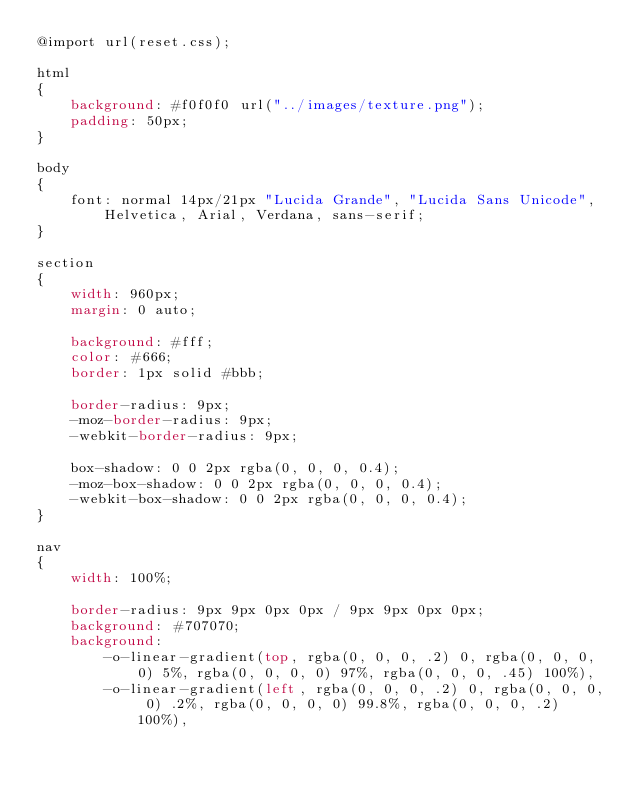<code> <loc_0><loc_0><loc_500><loc_500><_CSS_>@import url(reset.css);

html
{
	background: #f0f0f0 url("../images/texture.png");
	padding: 50px;
}

body
{
	font: normal 14px/21px "Lucida Grande", "Lucida Sans Unicode", Helvetica, Arial, Verdana, sans-serif;
}

section
{
	width: 960px;
	margin: 0 auto;

	background: #fff;
	color: #666;
	border: 1px solid #bbb;

	border-radius: 9px;
	-moz-border-radius: 9px;
	-webkit-border-radius: 9px;

	box-shadow: 0 0 2px rgba(0, 0, 0, 0.4);
	-moz-box-shadow: 0 0 2px rgba(0, 0, 0, 0.4);
	-webkit-box-shadow: 0 0 2px rgba(0, 0, 0, 0.4);
}

nav
{
    width: 100%;
    
    border-radius: 9px 9px 0px 0px / 9px 9px 0px 0px;
    background: #707070;
    background:
		-o-linear-gradient(top, rgba(0, 0, 0, .2) 0, rgba(0, 0, 0, 0) 5%, rgba(0, 0, 0, 0) 97%, rgba(0, 0, 0, .45) 100%),
		-o-linear-gradient(left, rgba(0, 0, 0, .2) 0, rgba(0, 0, 0, 0) .2%, rgba(0, 0, 0, 0) 99.8%, rgba(0, 0, 0, .2) 100%),</code> 